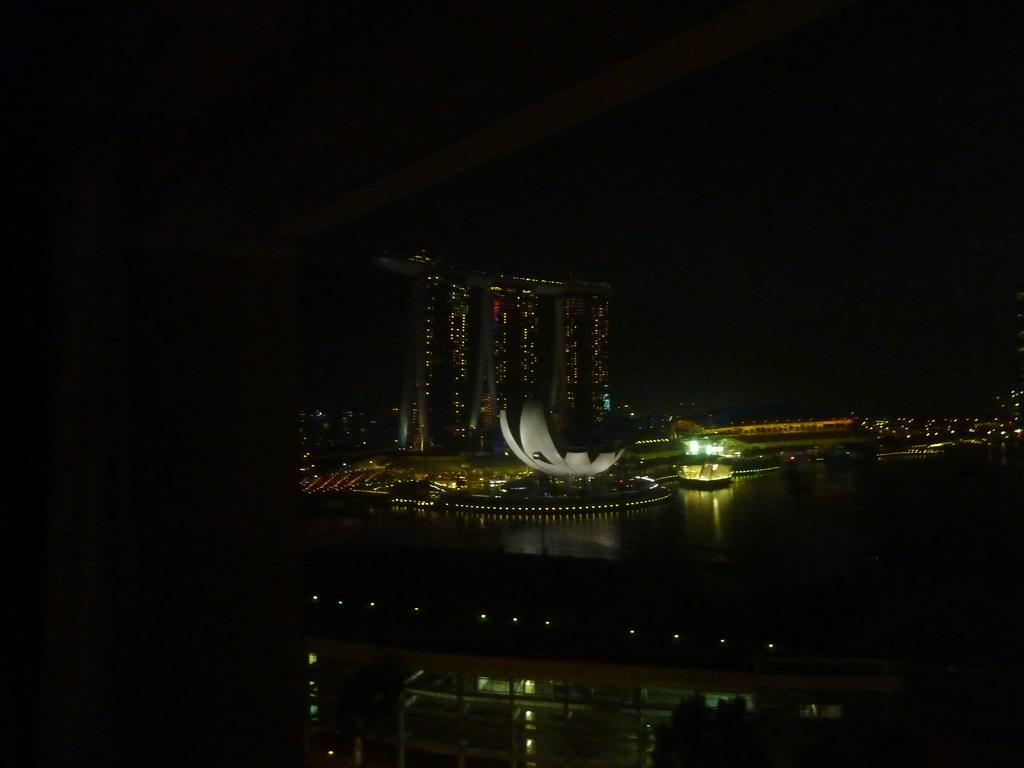What is the main structure in the center of the image? There is a building in the center of the image. What type of vehicle can be seen in the image? There is a boat in the image. What is the surrounding environment like in the image? There is water visible in the image. What can be seen illuminating the scene in the image? Lights are present in the image. What is visible at the top of the image? The sky is visible at the top of the image. Can you tell me where the spy is hiding in the image? There is no spy present in the image. What type of plant is growing near the boat in the image? There is no plant visible in the image. 